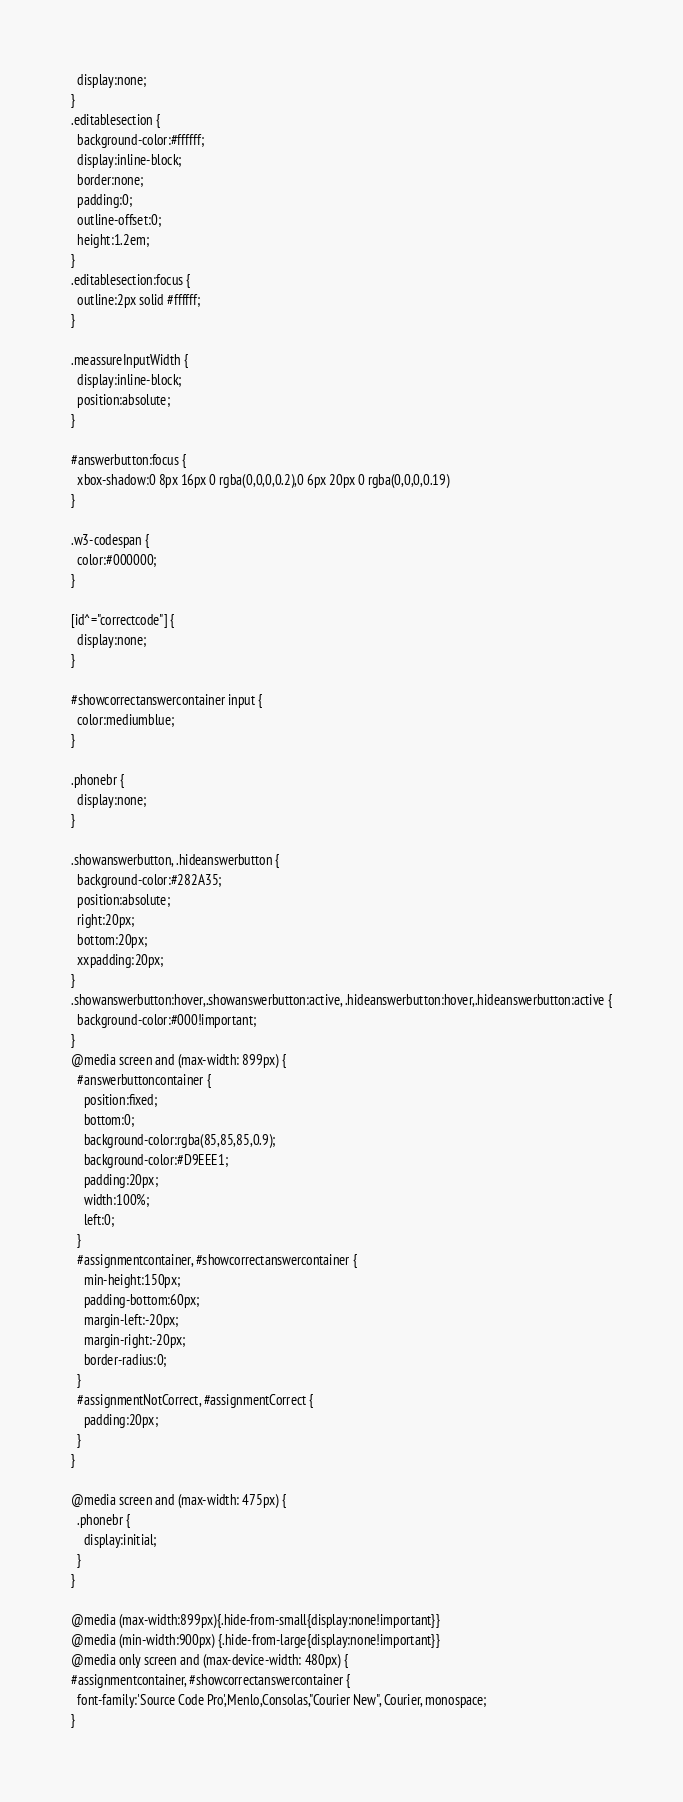Convert code to text. <code><loc_0><loc_0><loc_500><loc_500><_HTML_>  display:none;
}
.editablesection {
  background-color:#ffffff;
  display:inline-block;
  border:none;
  padding:0;
  outline-offset:0;
  height:1.2em;
}
.editablesection:focus {
  outline:2px solid #ffffff;
}

.meassureInputWidth {
  display:inline-block;
  position:absolute;
}

#answerbutton:focus {
  xbox-shadow:0 8px 16px 0 rgba(0,0,0,0.2),0 6px 20px 0 rgba(0,0,0,0.19)
}

.w3-codespan {
  color:#000000;
}

[id^="correctcode"] {
  display:none;
}

#showcorrectanswercontainer input {
  color:mediumblue;
}

.phonebr {
  display:none;
}

.showanswerbutton, .hideanswerbutton {
  background-color:#282A35;
  position:absolute;
  right:20px;
  bottom:20px;
  xxpadding:20px;
}
.showanswerbutton:hover,.showanswerbutton:active, .hideanswerbutton:hover,.hideanswerbutton:active {
  background-color:#000!important;
}
@media screen and (max-width: 899px) {
  #answerbuttoncontainer {
    position:fixed;
    bottom:0;
    background-color:rgba(85,85,85,0.9);
    background-color:#D9EEE1;
    padding:20px;
    width:100%;
    left:0;
  }
  #assignmentcontainer, #showcorrectanswercontainer {
    min-height:150px;
    padding-bottom:60px;
    margin-left:-20px;
    margin-right:-20px;
    border-radius:0;
  }
  #assignmentNotCorrect, #assignmentCorrect {
    padding:20px;
  }
}

@media screen and (max-width: 475px) {
  .phonebr {
    display:initial;
  }
}

@media (max-width:899px){.hide-from-small{display:none!important}}
@media (min-width:900px) {.hide-from-large{display:none!important}}
@media only screen and (max-device-width: 480px) {
#assignmentcontainer, #showcorrectanswercontainer {
  font-family:'Source Code Pro',Menlo,Consolas,"Courier New", Courier, monospace;
}</code> 